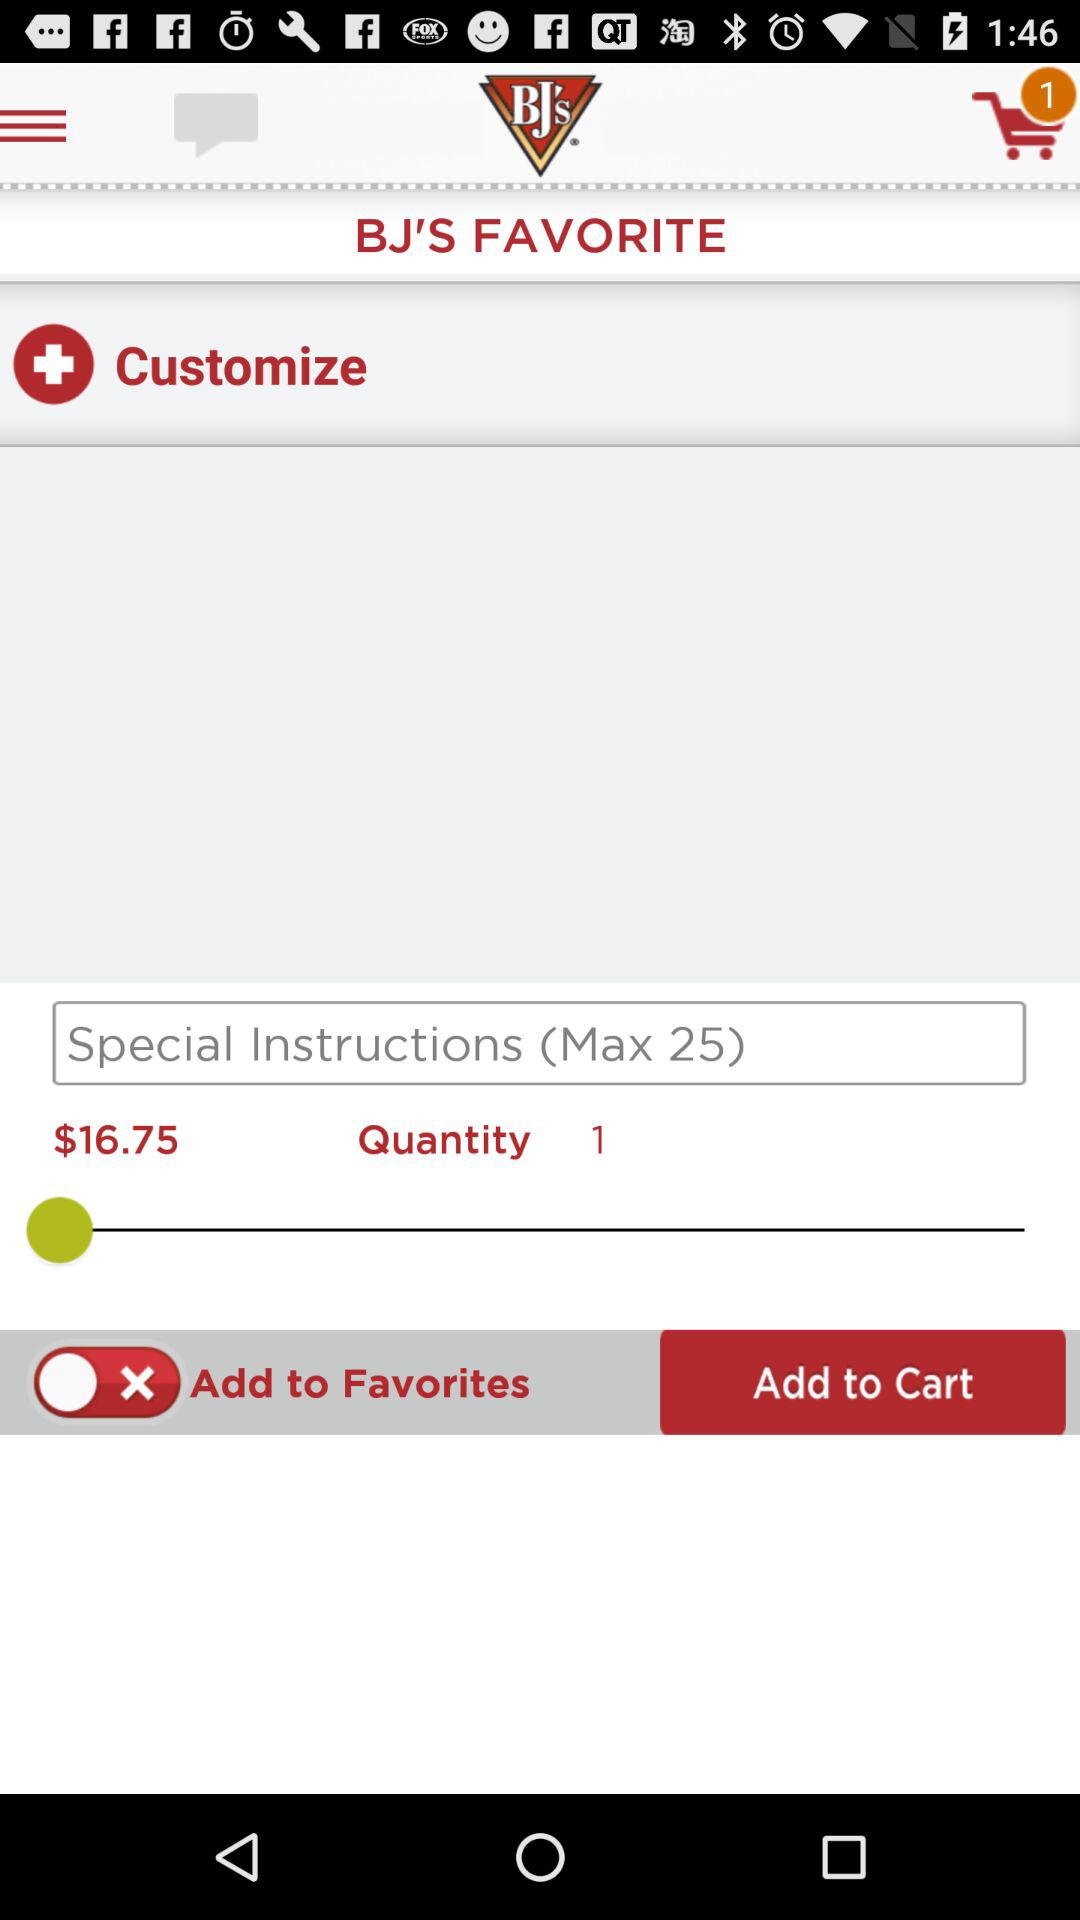What is the price of the item before customizing?
Answer the question using a single word or phrase. $16.75 